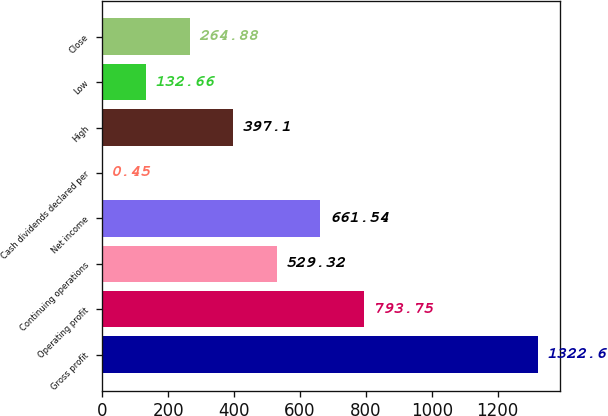Convert chart. <chart><loc_0><loc_0><loc_500><loc_500><bar_chart><fcel>Gross profit<fcel>Operating profit<fcel>Continuing operations<fcel>Net income<fcel>Cash dividends declared per<fcel>High<fcel>Low<fcel>Close<nl><fcel>1322.6<fcel>793.75<fcel>529.32<fcel>661.54<fcel>0.45<fcel>397.1<fcel>132.66<fcel>264.88<nl></chart> 